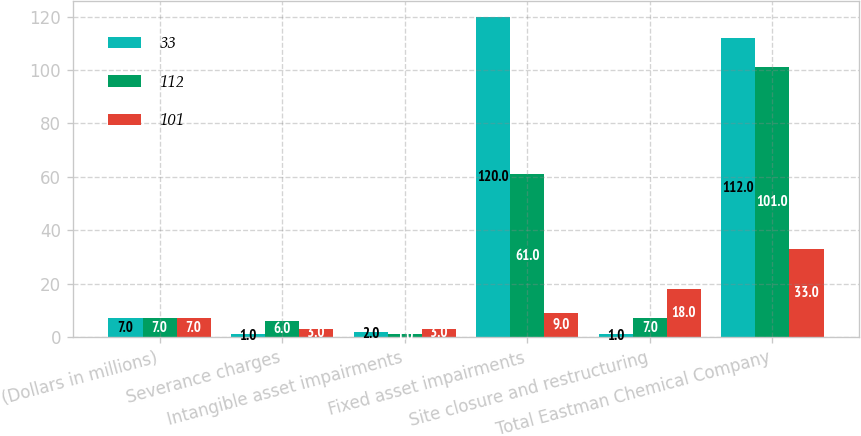Convert chart to OTSL. <chart><loc_0><loc_0><loc_500><loc_500><stacked_bar_chart><ecel><fcel>(Dollars in millions)<fcel>Severance charges<fcel>Intangible asset impairments<fcel>Fixed asset impairments<fcel>Site closure and restructuring<fcel>Total Eastman Chemical Company<nl><fcel>33<fcel>7<fcel>1<fcel>2<fcel>120<fcel>1<fcel>112<nl><fcel>112<fcel>7<fcel>6<fcel>1<fcel>61<fcel>7<fcel>101<nl><fcel>101<fcel>7<fcel>3<fcel>3<fcel>9<fcel>18<fcel>33<nl></chart> 